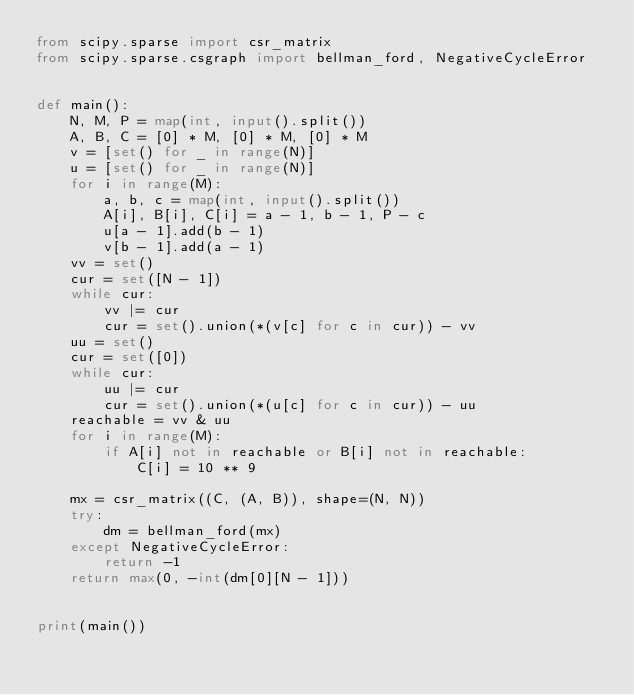Convert code to text. <code><loc_0><loc_0><loc_500><loc_500><_Python_>from scipy.sparse import csr_matrix
from scipy.sparse.csgraph import bellman_ford, NegativeCycleError


def main():
    N, M, P = map(int, input().split())
    A, B, C = [0] * M, [0] * M, [0] * M
    v = [set() for _ in range(N)]
    u = [set() for _ in range(N)]
    for i in range(M):
        a, b, c = map(int, input().split())
        A[i], B[i], C[i] = a - 1, b - 1, P - c
        u[a - 1].add(b - 1)
        v[b - 1].add(a - 1)
    vv = set()
    cur = set([N - 1])
    while cur:
        vv |= cur
        cur = set().union(*(v[c] for c in cur)) - vv
    uu = set()
    cur = set([0])
    while cur:
        uu |= cur
        cur = set().union(*(u[c] for c in cur)) - uu
    reachable = vv & uu
    for i in range(M):
        if A[i] not in reachable or B[i] not in reachable:
            C[i] = 10 ** 9

    mx = csr_matrix((C, (A, B)), shape=(N, N))
    try:
        dm = bellman_ford(mx)
    except NegativeCycleError:
        return -1
    return max(0, -int(dm[0][N - 1]))


print(main())
</code> 